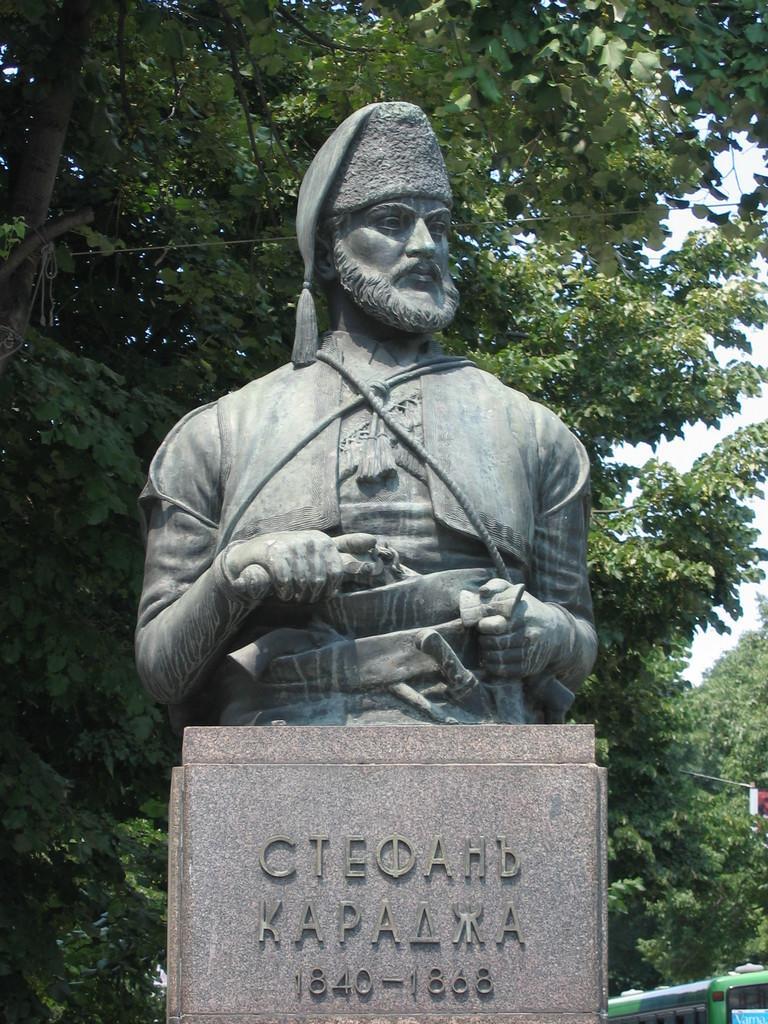In one or two sentences, can you explain what this image depicts? In the center of the image there is a statue. In the background we can see trees and sky. 